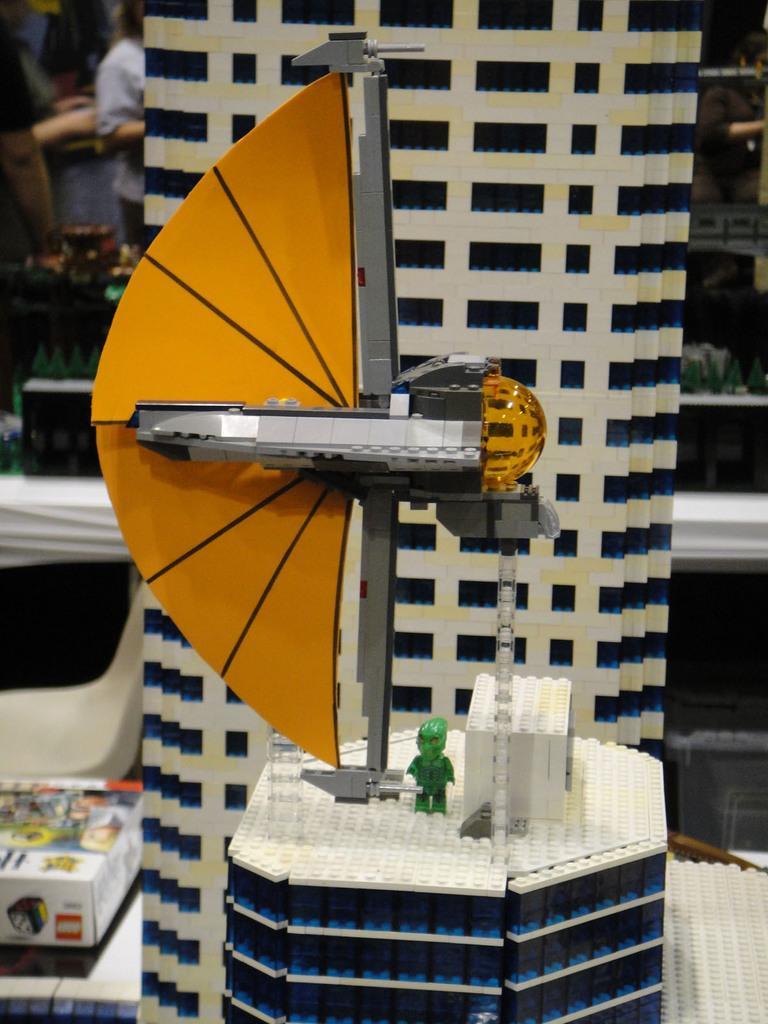Could you give a brief overview of what you see in this image? In this image there is a scale model, in the background it is blurred. 